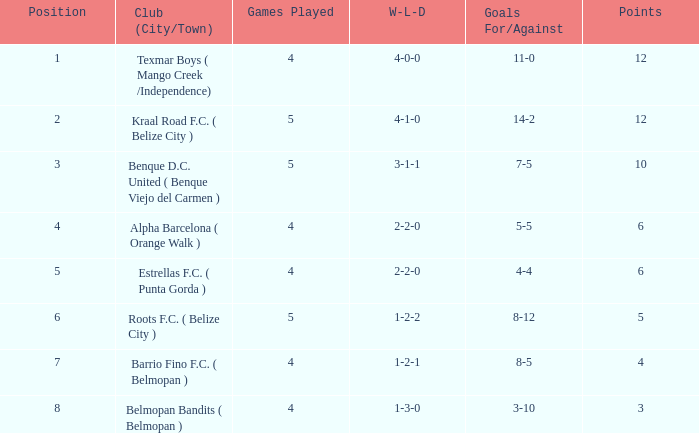What is the minimum games played with goals for/against being 7-5 5.0. Would you be able to parse every entry in this table? {'header': ['Position', 'Club (City/Town)', 'Games Played', 'W-L-D', 'Goals For/Against', 'Points'], 'rows': [['1', 'Texmar Boys ( Mango Creek /Independence)', '4', '4-0-0', '11-0', '12'], ['2', 'Kraal Road F.C. ( Belize City )', '5', '4-1-0', '14-2', '12'], ['3', 'Benque D.C. United ( Benque Viejo del Carmen )', '5', '3-1-1', '7-5', '10'], ['4', 'Alpha Barcelona ( Orange Walk )', '4', '2-2-0', '5-5', '6'], ['5', 'Estrellas F.C. ( Punta Gorda )', '4', '2-2-0', '4-4', '6'], ['6', 'Roots F.C. ( Belize City )', '5', '1-2-2', '8-12', '5'], ['7', 'Barrio Fino F.C. ( Belmopan )', '4', '1-2-1', '8-5', '4'], ['8', 'Belmopan Bandits ( Belmopan )', '4', '1-3-0', '3-10', '3']]} 